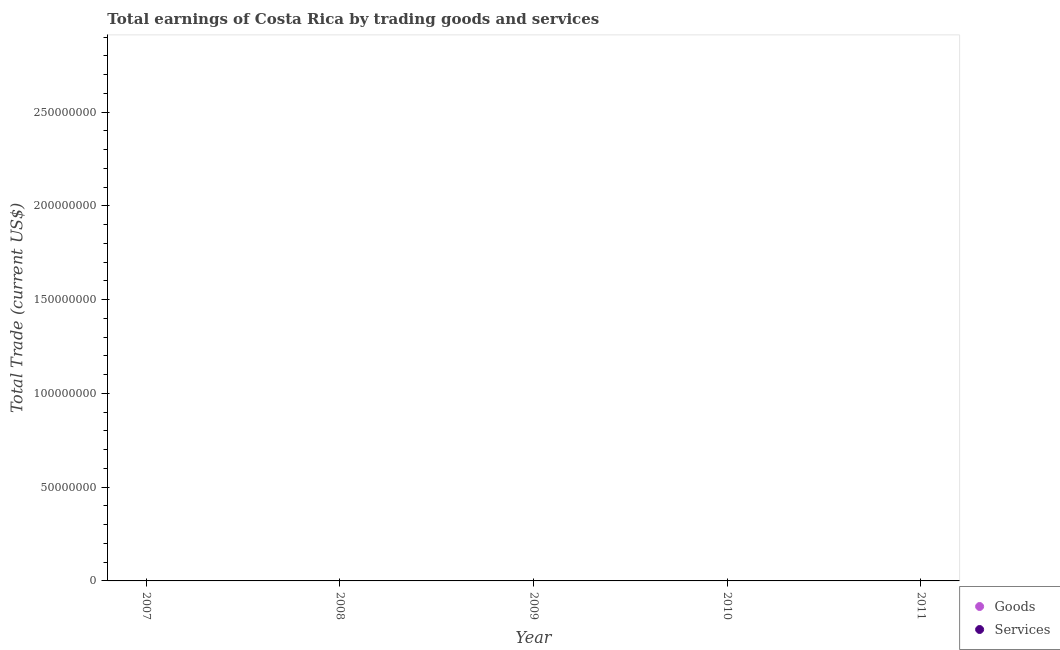How many different coloured dotlines are there?
Give a very brief answer. 0. Is the number of dotlines equal to the number of legend labels?
Keep it short and to the point. No. What is the total amount earned by trading goods in the graph?
Provide a succinct answer. 0. What is the difference between the amount earned by trading goods in 2007 and the amount earned by trading services in 2009?
Give a very brief answer. 0. What is the average amount earned by trading services per year?
Keep it short and to the point. 0. In how many years, is the amount earned by trading goods greater than 250000000 US$?
Your answer should be very brief. 0. Is the amount earned by trading services strictly greater than the amount earned by trading goods over the years?
Keep it short and to the point. Yes. Is the amount earned by trading goods strictly less than the amount earned by trading services over the years?
Offer a terse response. Yes. How many dotlines are there?
Provide a short and direct response. 0. Does the graph contain grids?
Ensure brevity in your answer.  No. Where does the legend appear in the graph?
Give a very brief answer. Bottom right. What is the title of the graph?
Your response must be concise. Total earnings of Costa Rica by trading goods and services. What is the label or title of the Y-axis?
Give a very brief answer. Total Trade (current US$). What is the Total Trade (current US$) of Services in 2007?
Provide a short and direct response. 0. What is the Total Trade (current US$) of Services in 2009?
Ensure brevity in your answer.  0. What is the Total Trade (current US$) in Services in 2010?
Make the answer very short. 0. What is the Total Trade (current US$) of Goods in 2011?
Offer a very short reply. 0. What is the Total Trade (current US$) of Services in 2011?
Provide a succinct answer. 0. What is the total Total Trade (current US$) of Goods in the graph?
Your answer should be compact. 0. What is the average Total Trade (current US$) in Services per year?
Your response must be concise. 0. 